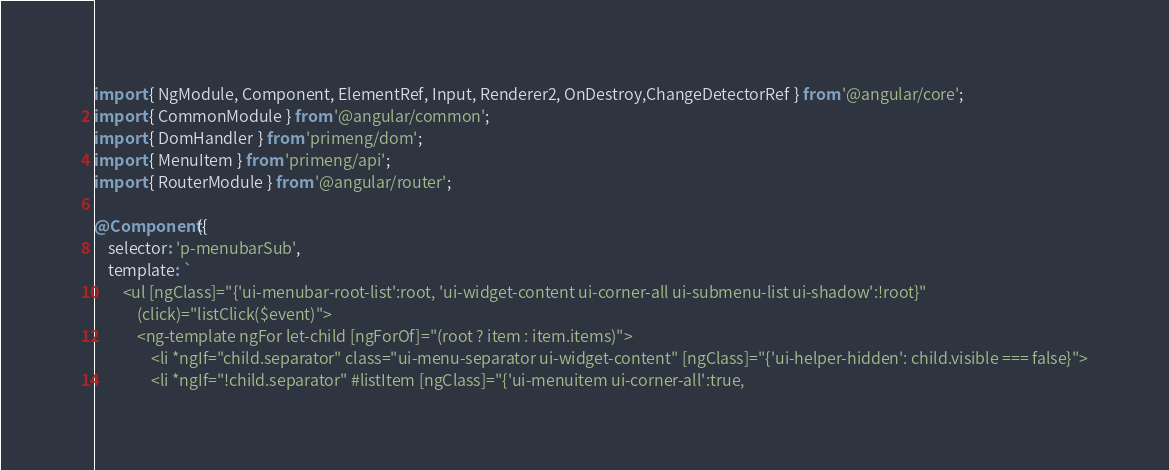<code> <loc_0><loc_0><loc_500><loc_500><_TypeScript_>import { NgModule, Component, ElementRef, Input, Renderer2, OnDestroy,ChangeDetectorRef } from '@angular/core';
import { CommonModule } from '@angular/common';
import { DomHandler } from 'primeng/dom';
import { MenuItem } from 'primeng/api';
import { RouterModule } from '@angular/router';

@Component({
    selector: 'p-menubarSub',
    template: `
        <ul [ngClass]="{'ui-menubar-root-list':root, 'ui-widget-content ui-corner-all ui-submenu-list ui-shadow':!root}"
            (click)="listClick($event)">
            <ng-template ngFor let-child [ngForOf]="(root ? item : item.items)">
                <li *ngIf="child.separator" class="ui-menu-separator ui-widget-content" [ngClass]="{'ui-helper-hidden': child.visible === false}">
                <li *ngIf="!child.separator" #listItem [ngClass]="{'ui-menuitem ui-corner-all':true,</code> 